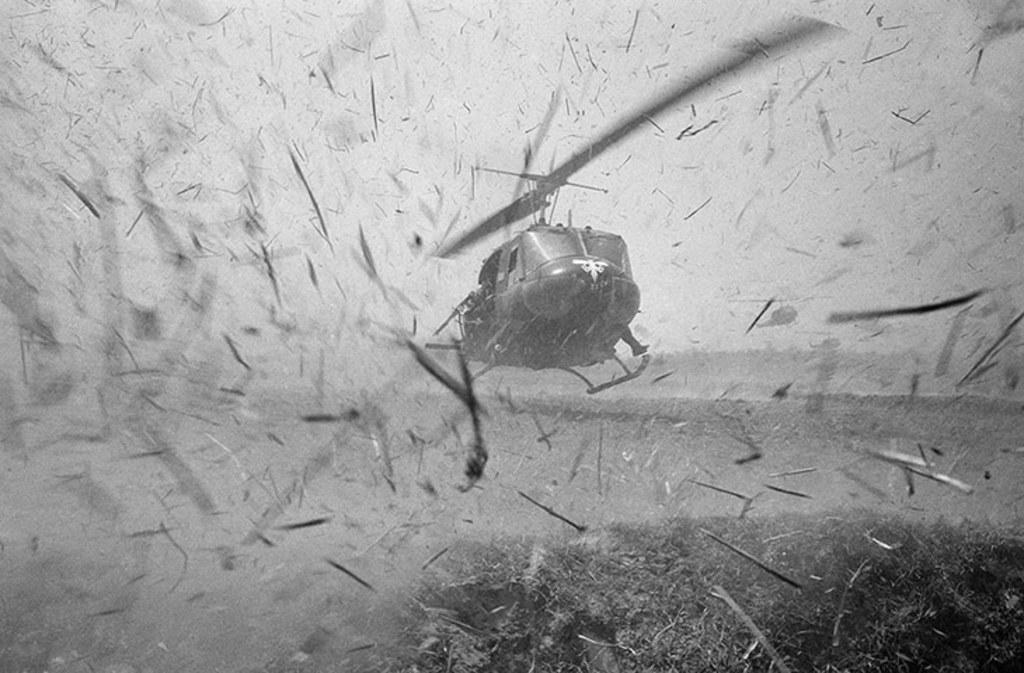What is the color scheme of the image? The image is black and white. What type of vehicle can be seen in the image? There is a helicopter in the image. Can you tell me how many donkeys are present in the image? There are no donkeys present in the image; it features a helicopter in a black and white setting. 